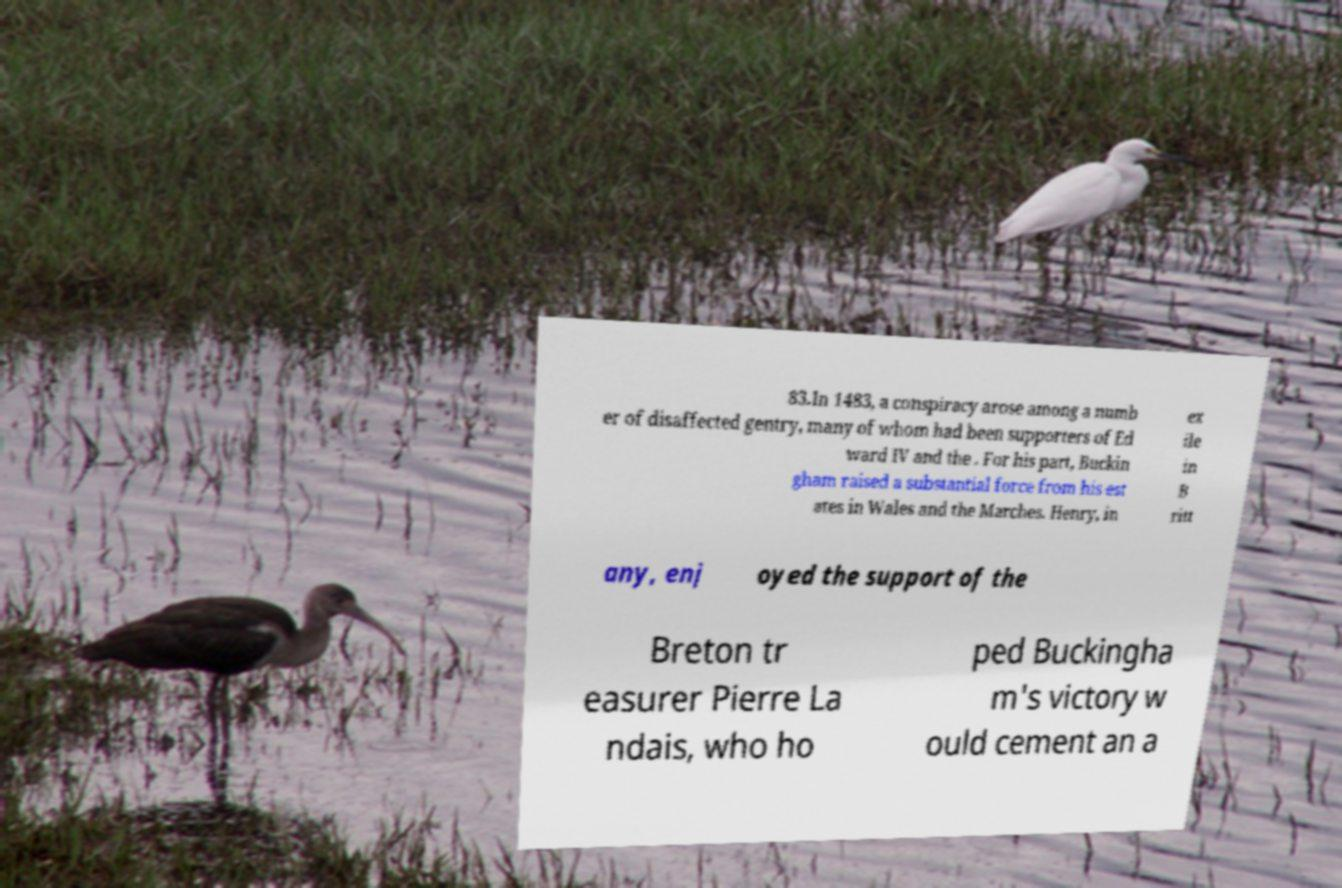Please read and relay the text visible in this image. What does it say? 83.In 1483, a conspiracy arose among a numb er of disaffected gentry, many of whom had been supporters of Ed ward IV and the . For his part, Buckin gham raised a substantial force from his est ates in Wales and the Marches. Henry, in ex ile in B ritt any, enj oyed the support of the Breton tr easurer Pierre La ndais, who ho ped Buckingha m's victory w ould cement an a 